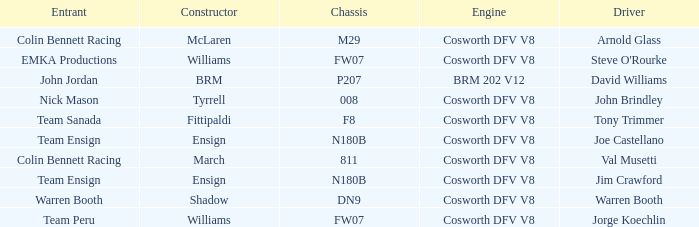What engine is used by Colin Bennett Racing with an 811 chassis? Cosworth DFV V8. 